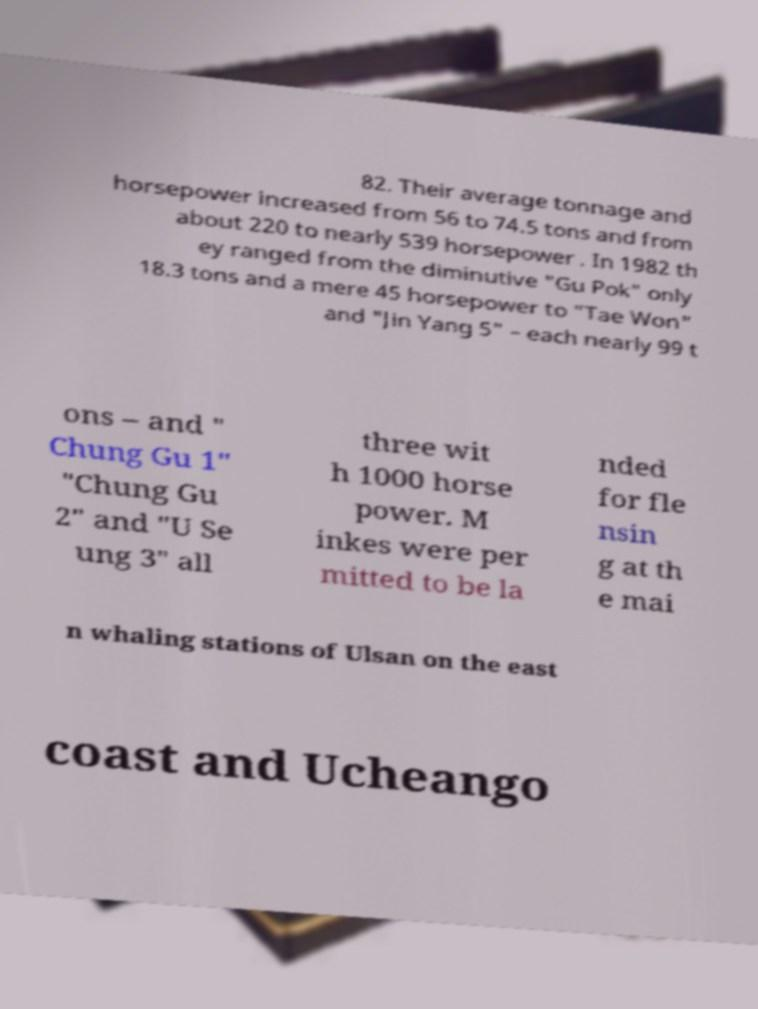There's text embedded in this image that I need extracted. Can you transcribe it verbatim? 82. Their average tonnage and horsepower increased from 56 to 74.5 tons and from about 220 to nearly 539 horsepower . In 1982 th ey ranged from the diminutive "Gu Pok" only 18.3 tons and a mere 45 horsepower to "Tae Won" and "Jin Yang 5" – each nearly 99 t ons – and " Chung Gu 1" "Chung Gu 2" and "U Se ung 3" all three wit h 1000 horse power. M inkes were per mitted to be la nded for fle nsin g at th e mai n whaling stations of Ulsan on the east coast and Ucheango 